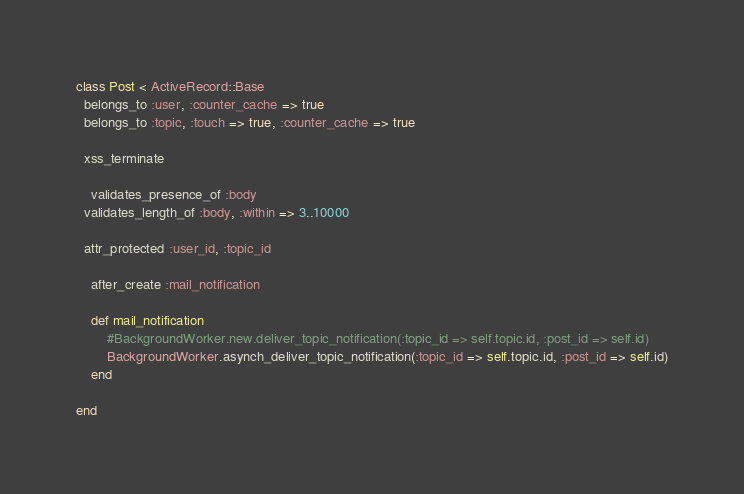<code> <loc_0><loc_0><loc_500><loc_500><_Ruby_>class Post < ActiveRecord::Base
  belongs_to :user, :counter_cache => true
  belongs_to :topic, :touch => true, :counter_cache => true

  xss_terminate
	
	validates_presence_of :body
  validates_length_of :body, :within => 3..10000
  
  attr_protected :user_id, :topic_id
  
	after_create :mail_notification
	
	def mail_notification
		#BackgroundWorker.new.deliver_topic_notification(:topic_id => self.topic.id, :post_id => self.id)
		BackgroundWorker.asynch_deliver_topic_notification(:topic_id => self.topic.id, :post_id => self.id)
	end

end
</code> 